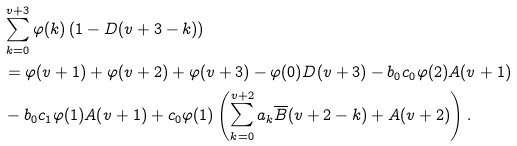Convert formula to latex. <formula><loc_0><loc_0><loc_500><loc_500>& \sum _ { k = 0 } ^ { v + 3 } \varphi ( k ) \left ( 1 - D ( v + 3 - k ) \right ) \\ & = \varphi ( v + 1 ) + \varphi ( v + 2 ) + \varphi ( v + 3 ) - \varphi ( 0 ) D ( v + 3 ) - b _ { 0 } c _ { 0 } \varphi ( 2 ) A ( v + 1 ) \\ & - b _ { 0 } c _ { 1 } \varphi ( 1 ) A ( v + 1 ) + c _ { 0 } \varphi ( 1 ) \left ( \sum _ { k = 0 } ^ { v + 2 } a _ { k } \overline { B } ( v + 2 - k ) + A ( v + 2 ) \right ) .</formula> 